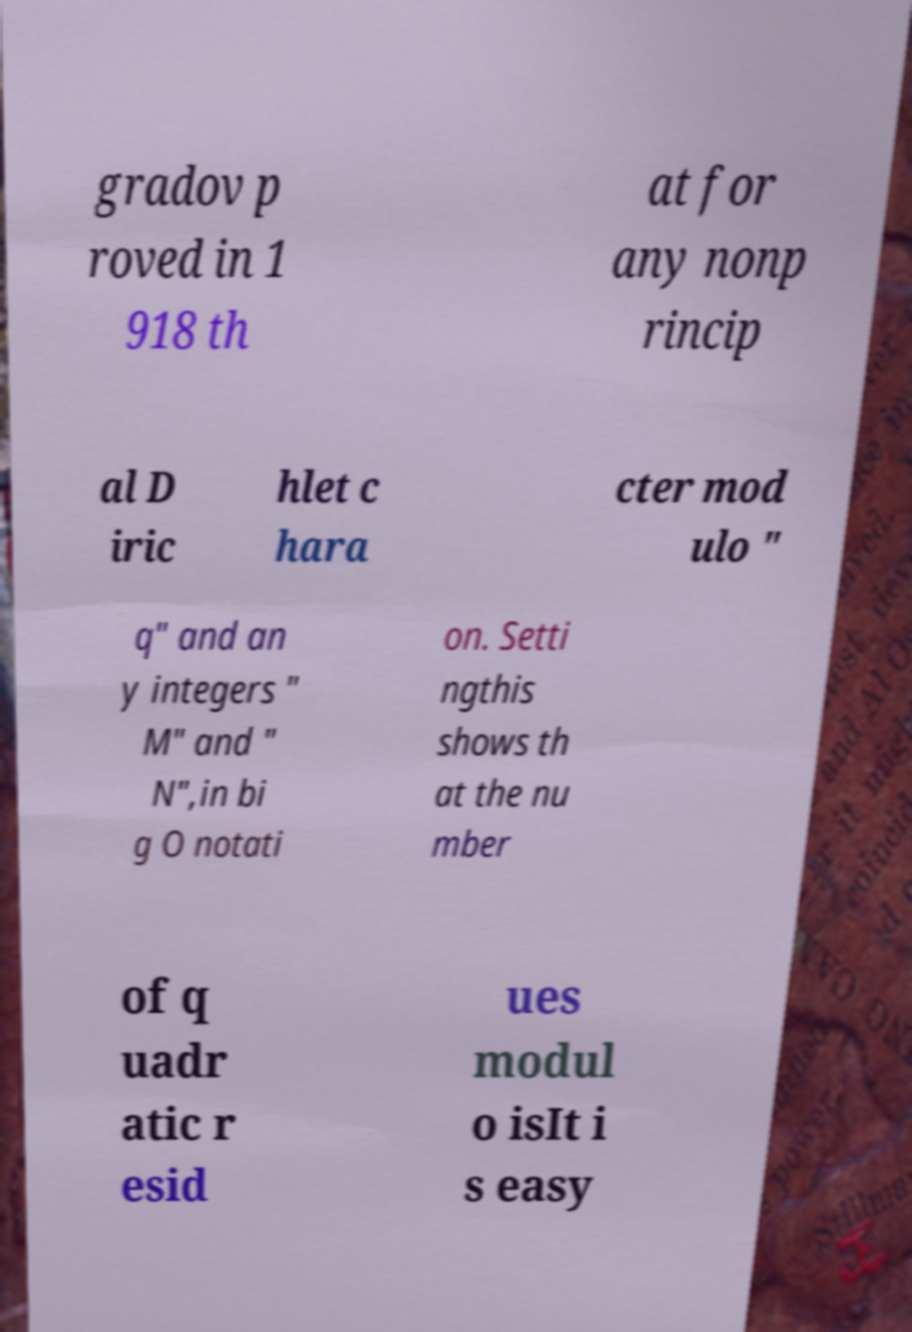Could you extract and type out the text from this image? gradov p roved in 1 918 th at for any nonp rincip al D iric hlet c hara cter mod ulo " q" and an y integers " M" and " N",in bi g O notati on. Setti ngthis shows th at the nu mber of q uadr atic r esid ues modul o isIt i s easy 